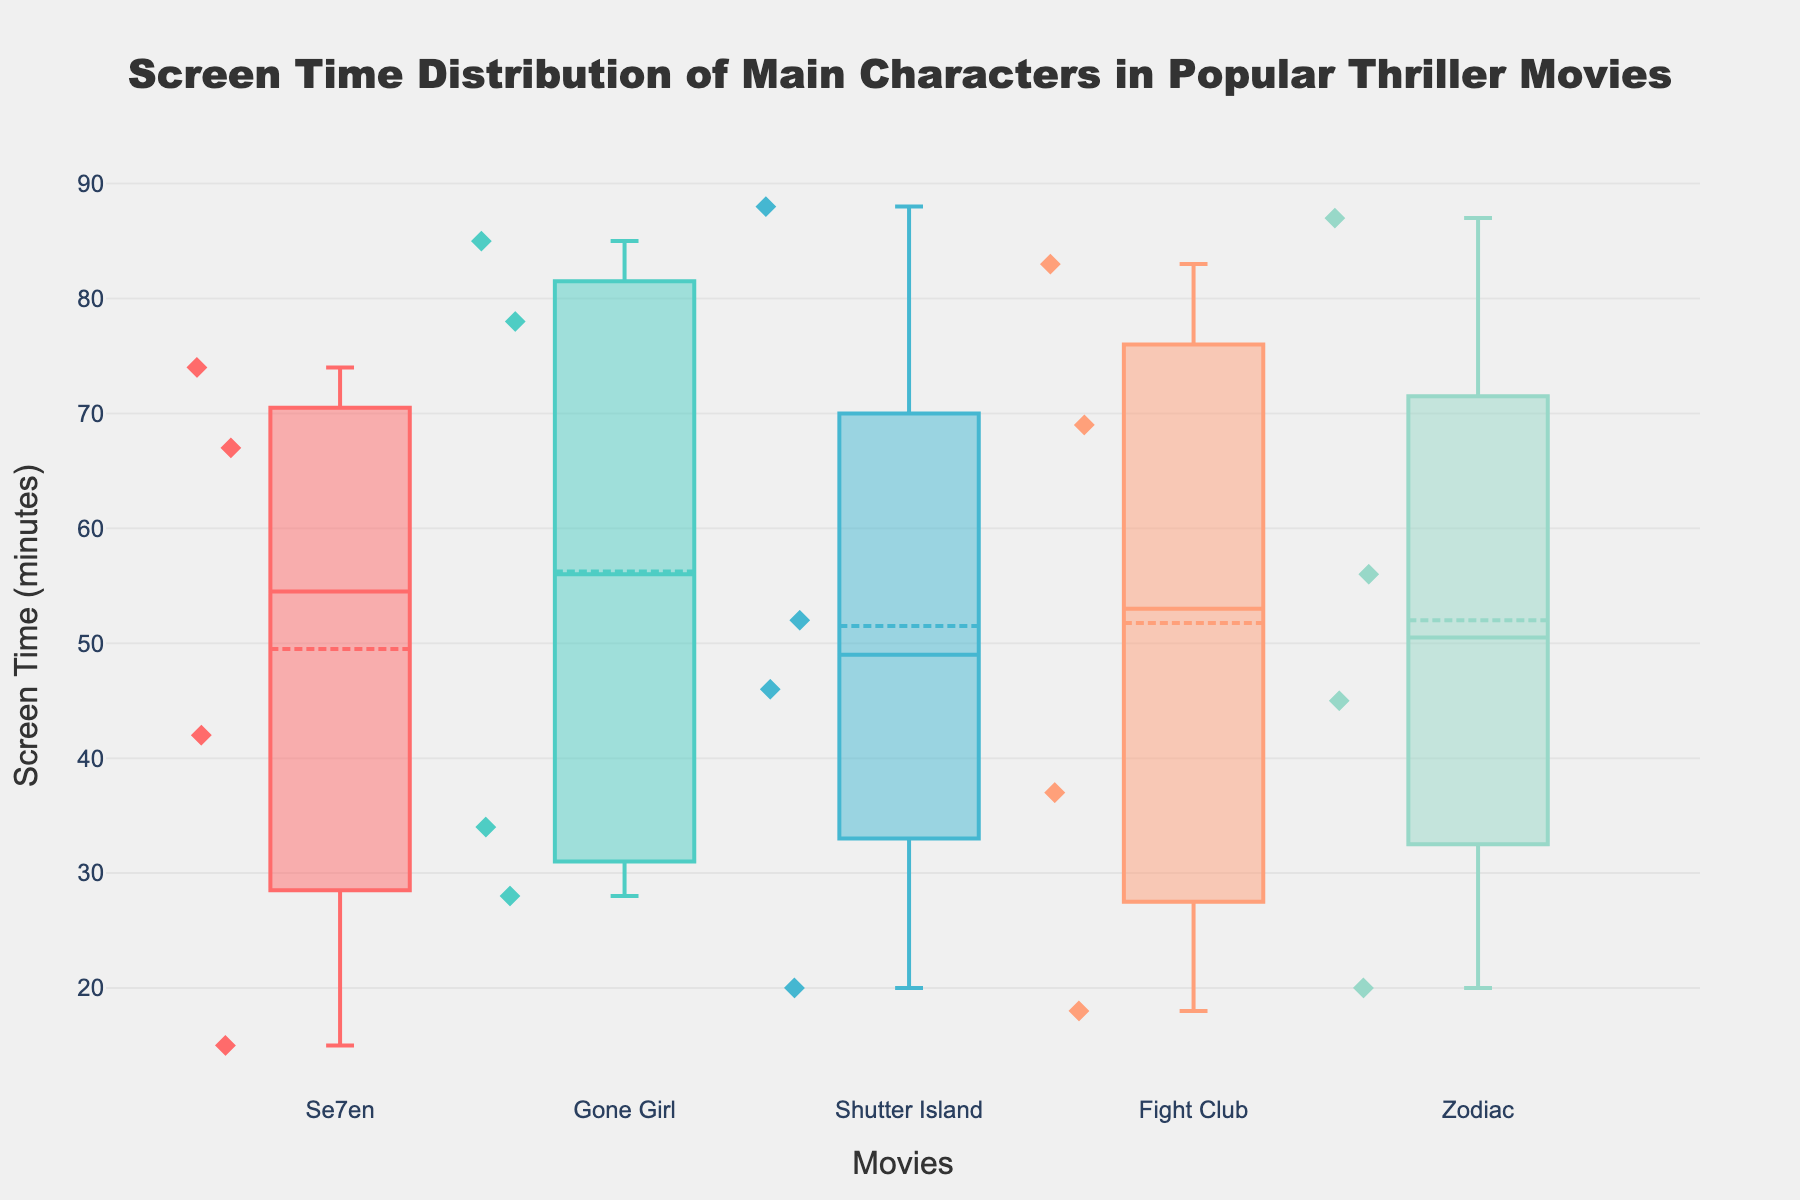What's the median screen time for the characters in Gone Girl? To find the median screen time for Gone Girl, we look at the box plot for that movie. The median is the middle line within the box, corresponding to the middle data point when sorted.
Answer: 56 minutes How many characters have more than 60 minutes of screen time in Shutter Island? In the box plot for Shutter Island, we look at the individual points shown. Only Teddy Daniels has screen time over 60 minutes.
Answer: 1 character Which movie has the widest range of screen time distribution? The range is determined by the length of the whiskers on the box plot. Fight Club has the widest range since its whiskers are the longest from the minimum to the maximum.
Answer: Fight Club What is the average screen time for the main characters in Se7en? First, sum the screen times for all characters in Se7en: 42 + 67 + 74 + 15 = 198. There are 4 characters, so the average is 198 / 4.
Answer: 49.5 minutes Which movie has the least variation in screen time among its main characters? The movie with the smallest interquartile range (IQR) on the box plot shows the least variation. Se7en has the smallest IQR among the movies.
Answer: Se7en Are there any outliers in Zodiac's screen time distribution? Outliers in a box plot are identifiable by points that fall outside the whiskers. In Zodiac, there are no points outside of the whiskers.
Answer: No How many characters in Gone Girl have less than 40 minutes of screen time? Observing the individual points on the box plot for Gone Girl, Detective Boney and Margo Dunne have less than 40 minutes of screen time.
Answer: 2 characters Which character has the maximum screen time among all movies? Examine the highest point across all box plots. Teddy Daniels in Shutter Island reaches 88 minutes.
Answer: Teddy Daniels What is the interquartile range (IQR) of screen time for Fight Club? The IQR is the difference between the third quartile (Q3) and the first quartile (Q1). For Fight Club, this is calculated as Q3 (83) - Q1 (28).
Answer: 55 minutes 